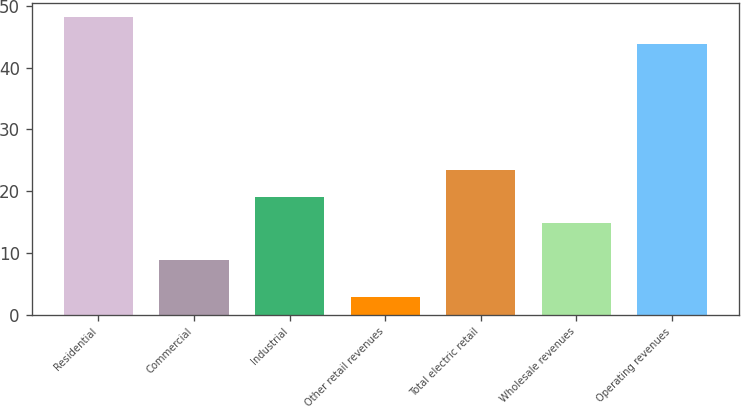Convert chart to OTSL. <chart><loc_0><loc_0><loc_500><loc_500><bar_chart><fcel>Residential<fcel>Commercial<fcel>Industrial<fcel>Other retail revenues<fcel>Total electric retail<fcel>Wholesale revenues<fcel>Operating revenues<nl><fcel>48.13<fcel>8.9<fcel>19.13<fcel>2.8<fcel>23.36<fcel>14.9<fcel>43.9<nl></chart> 